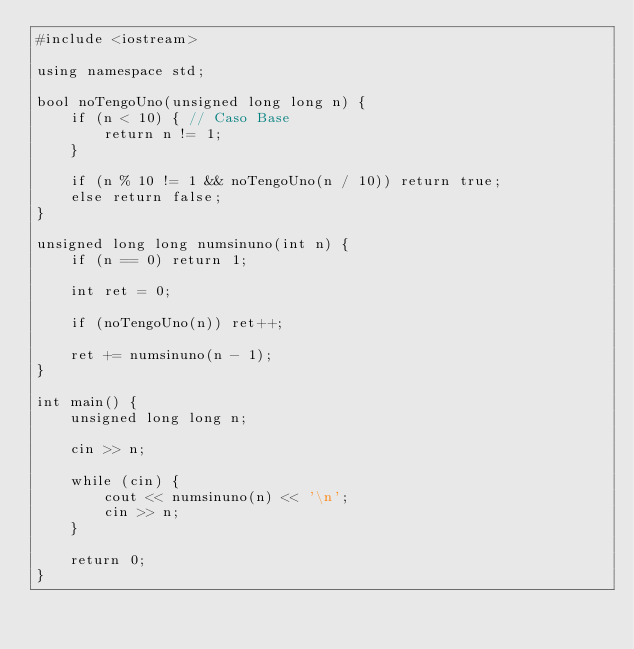Convert code to text. <code><loc_0><loc_0><loc_500><loc_500><_C++_>#include <iostream>

using namespace std;

bool noTengoUno(unsigned long long n) {
	if (n < 10) { // Caso Base
		return n != 1;
	}

	if (n % 10 != 1 && noTengoUno(n / 10)) return true;
	else return false;
}

unsigned long long numsinuno(int n) {
	if (n == 0) return 1;

	int ret = 0;

	if (noTengoUno(n)) ret++;

	ret += numsinuno(n - 1);
}

int main() {
	unsigned long long n;

	cin >> n;

	while (cin) {
		cout << numsinuno(n) << '\n';
		cin >> n;
	}

	return 0;
}</code> 